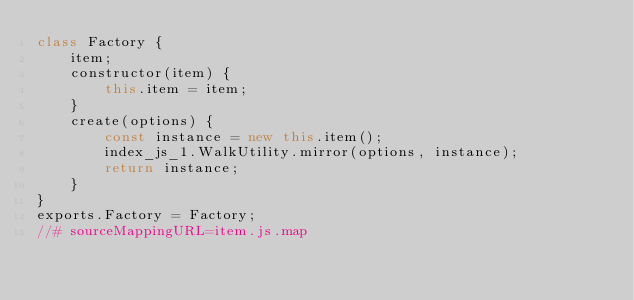Convert code to text. <code><loc_0><loc_0><loc_500><loc_500><_JavaScript_>class Factory {
    item;
    constructor(item) {
        this.item = item;
    }
    create(options) {
        const instance = new this.item();
        index_js_1.WalkUtility.mirror(options, instance);
        return instance;
    }
}
exports.Factory = Factory;
//# sourceMappingURL=item.js.map</code> 